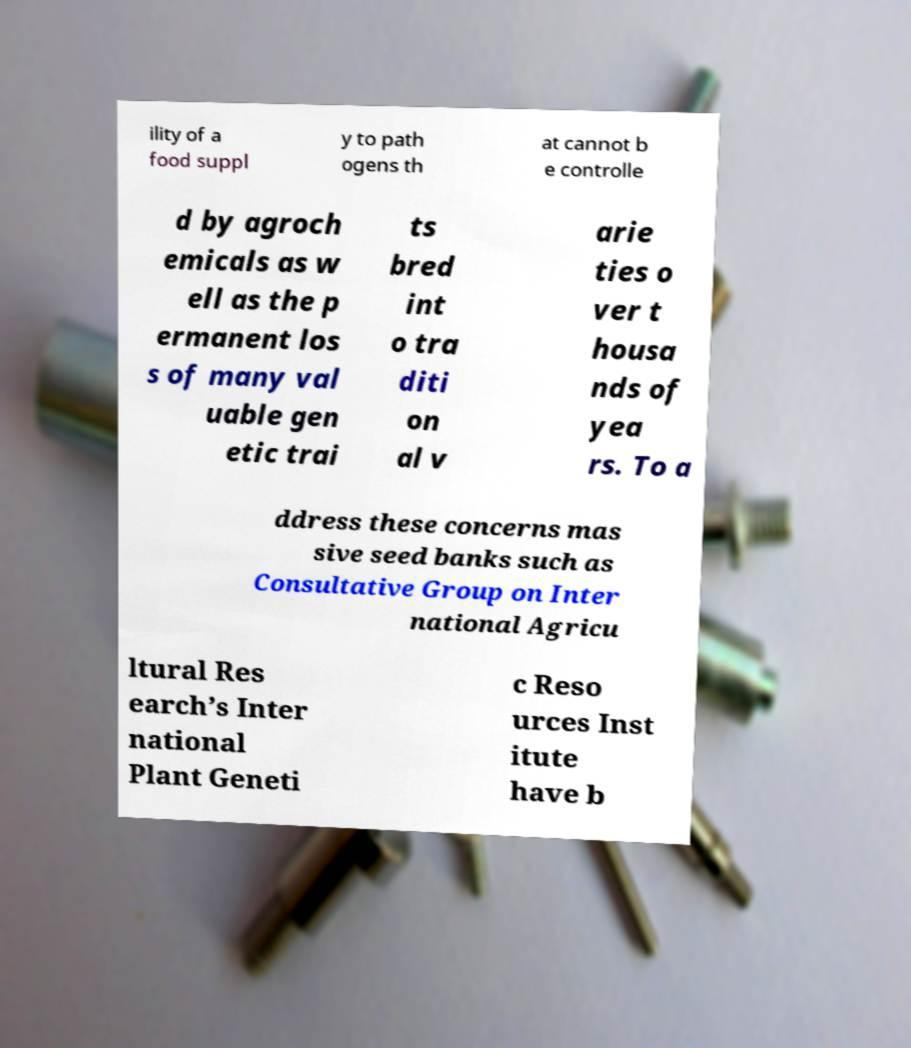Could you assist in decoding the text presented in this image and type it out clearly? ility of a food suppl y to path ogens th at cannot b e controlle d by agroch emicals as w ell as the p ermanent los s of many val uable gen etic trai ts bred int o tra diti on al v arie ties o ver t housa nds of yea rs. To a ddress these concerns mas sive seed banks such as Consultative Group on Inter national Agricu ltural Res earch’s Inter national Plant Geneti c Reso urces Inst itute have b 